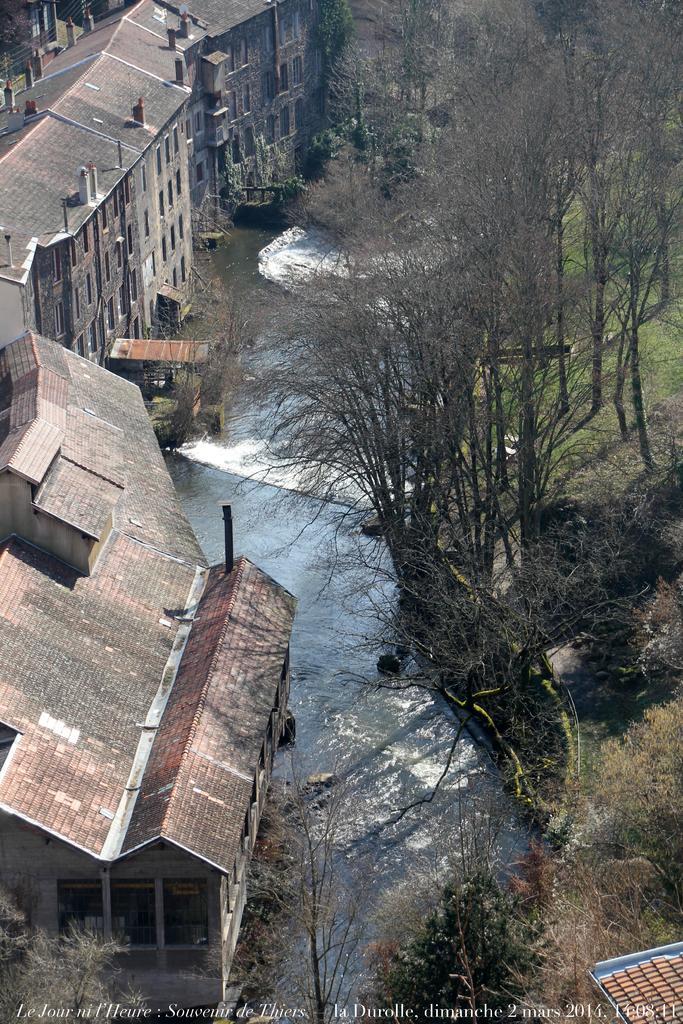Can you describe this image briefly? This picture shows few buildings and we see water and few trees and we see grass on the ground and we see text at the bottom of the picture. 